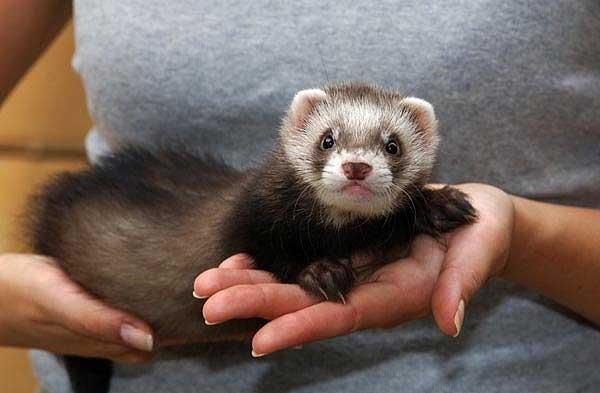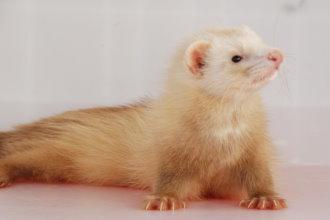The first image is the image on the left, the second image is the image on the right. For the images shown, is this caption "In one of the images there is one animal being held." true? Answer yes or no. Yes. The first image is the image on the left, the second image is the image on the right. Considering the images on both sides, is "The combined images contain four ferrets, at least three ferrets have raccoon-mask markings, and a human hand is grasping at least one ferret." valid? Answer yes or no. No. 